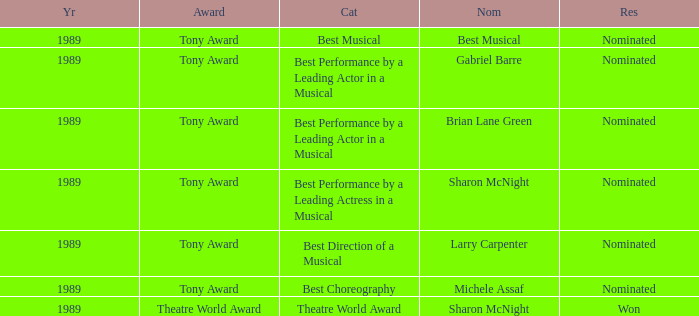What year was michele assaf nominated 1989.0. 